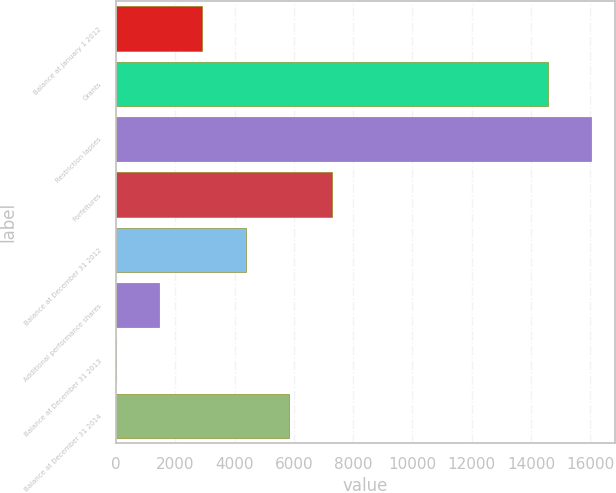<chart> <loc_0><loc_0><loc_500><loc_500><bar_chart><fcel>Balance at January 1 2012<fcel>Grants<fcel>Restriction lapses<fcel>Forfeitures<fcel>Balance at December 31 2012<fcel>Additional performance shares<fcel>Balance at December 31 2013<fcel>Balance at December 31 2014<nl><fcel>2916.64<fcel>14580<fcel>16037.9<fcel>7290.4<fcel>4374.56<fcel>1458.72<fcel>0.8<fcel>5832.48<nl></chart> 